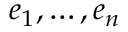<formula> <loc_0><loc_0><loc_500><loc_500>e _ { 1 } , \dots , e _ { n }</formula> 